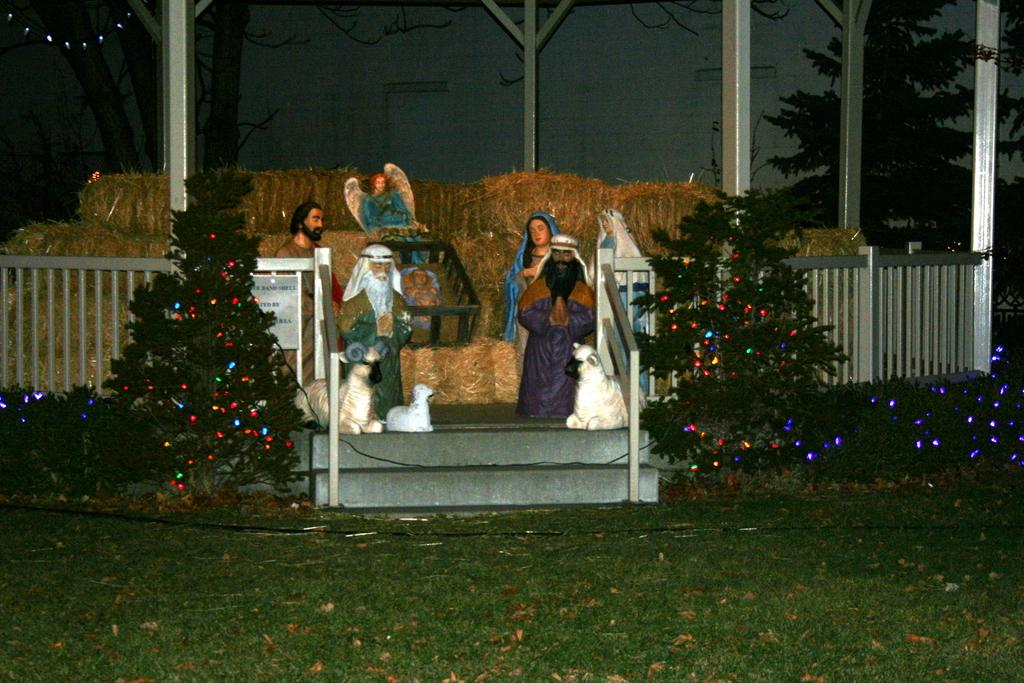What type of artwork can be seen in the image? There are sculptures in the image. What is located in front of the sculptures? There is a fence and metal rods in front of the sculptures. What type of vegetation is present in the image? There are trees in the image. What is attached to the trees in the image? Lights are visible on the trees. What type of afterthought is depicted in the image? There is no afterthought depicted in the image; the image features sculptures, a fence, metal rods, trees, and lights. What type of selection process was used to choose the sculptures in the image? The image does not provide information about the selection process used to choose the sculptures. 